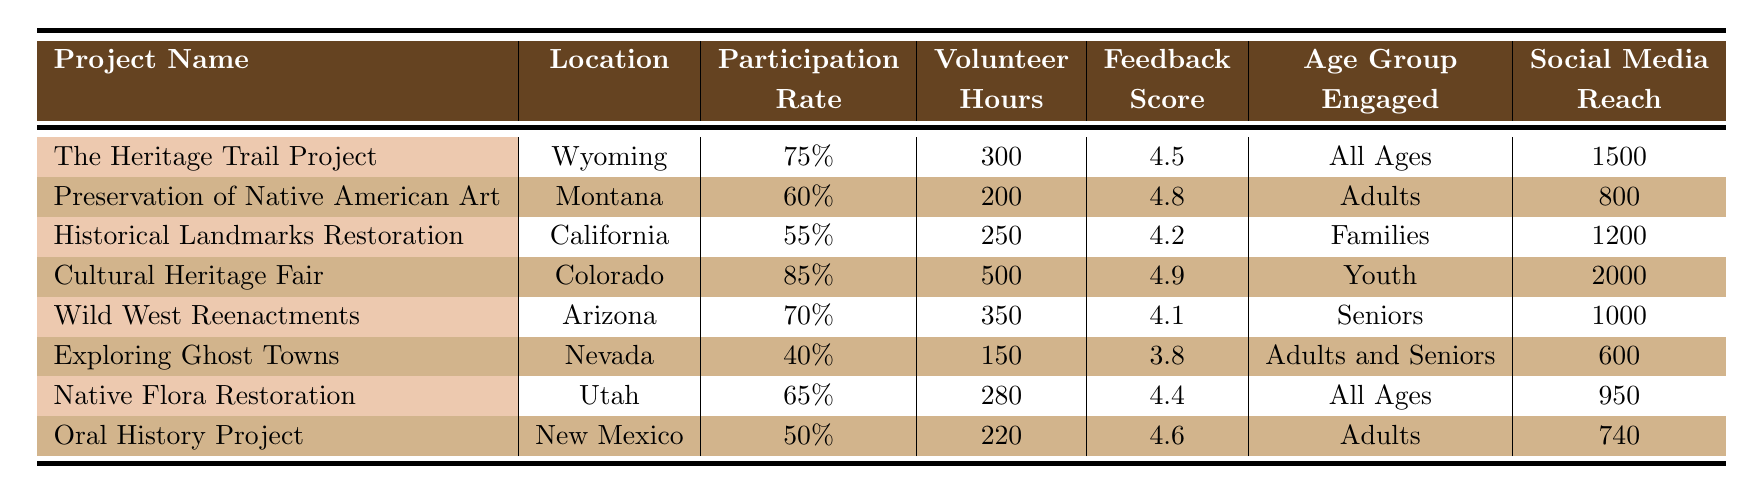What is the location of the "Cultural Heritage Fair" project? The project name "Cultural Heritage Fair" is listed in the table and is located in "Colorado."
Answer: Colorado Which project has the highest participation rate? Looking at the participation rates, "Cultural Heritage Fair" has a rate of 85%, which is higher than any other project listed.
Answer: Cultural Heritage Fair What is the total number of volunteer hours contributed across all projects? To find the total volunteer hours, sum the volunteer hours for all projects: 300 + 200 + 250 + 500 + 350 + 150 + 280 + 220 = 2250.
Answer: 2250 Is the community feedback score for "Exploring Ghost Towns" greater than 4? The community feedback score for "Exploring Ghost Towns" is 3.8, which is not greater than 4.
Answer: No Which project engaged all age groups and what was its social media reach? The projects engaging all age groups are "The Heritage Trail Project" and "Native Flora Restoration." "The Heritage Trail Project" has a social media reach of 1500, while "Native Flora Restoration" has 950.
Answer: The Heritage Trail Project, 1500 Calculate the average community feedback score of projects engaging adults. The projects engaging adults are "Preservation of Native American Art," "Oral History Project," and "Exploring Ghost Towns." Their feedback scores are 4.8, 4.6, and 3.8. Summing these gives 13.2, and averaging gives 13.2/3 = 4.4.
Answer: 4.4 Did the "Wild West Reenactments" project have more volunteer hours than the "Native Flora Restoration" project? "Wild West Reenactments" has 350 volunteer hours while "Native Flora Restoration" has 280. Since 350 is greater than 280, this statement is true.
Answer: Yes What age group is engaged in the "Historical Landmarks Restoration" project? The "Historical Landmarks Restoration" project lists "Families" as the engaged age group.
Answer: Families 